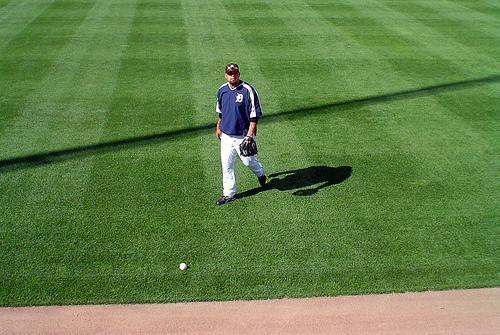How many players?
Give a very brief answer. 1. How many baseballs are in the air?
Give a very brief answer. 0. 